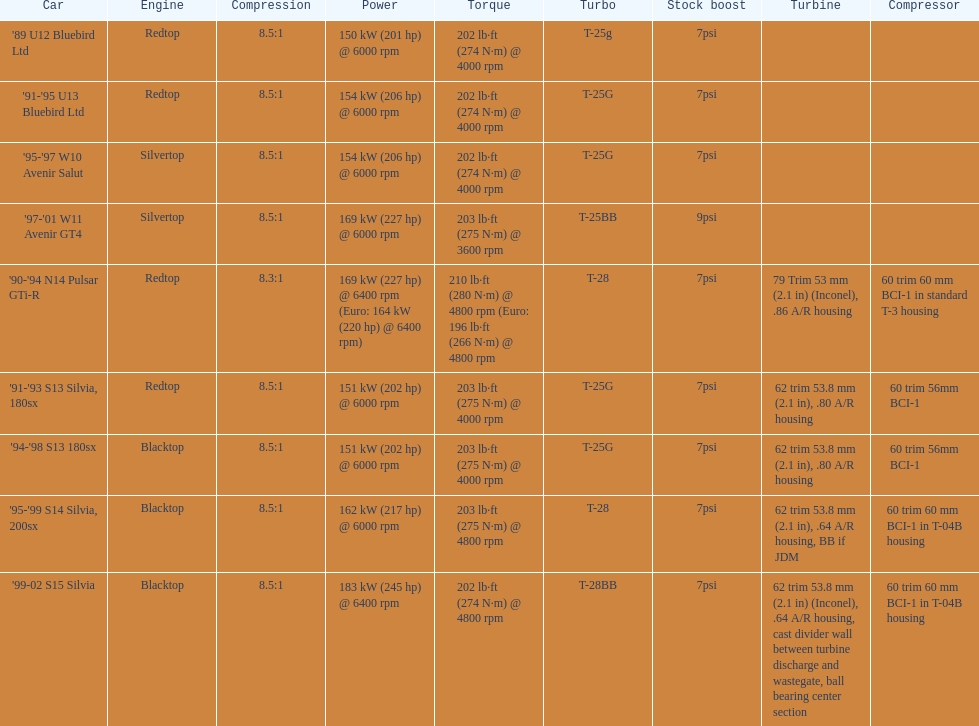What are the elements of the psi's? 7psi, 7psi, 7psi, 9psi, 7psi, 7psi, 7psi, 7psi, 7psi. Which figure(s) is above 7? 9psi. Which auto carries that particular digit? '97-'01 W11 Avenir GT4. 